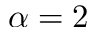<formula> <loc_0><loc_0><loc_500><loc_500>\alpha = 2</formula> 